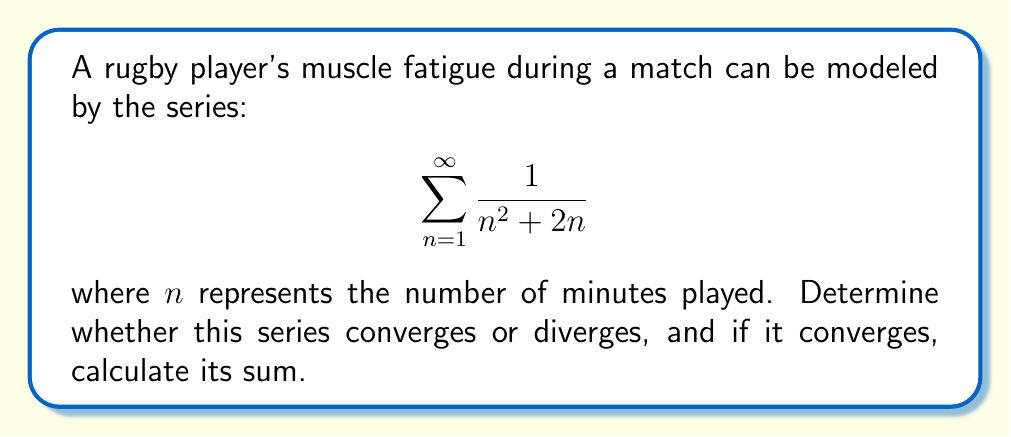Could you help me with this problem? To determine the convergence of this series, we can use the limit comparison test with a known convergent p-series.

Step 1: Choose a comparable series
Let's compare our series to the p-series $\sum_{n=1}^{\infty} \frac{1}{n^2}$, which is known to converge for $p > 1$.

Step 2: Calculate the limit of the ratio of the general terms
Let $a_n = \frac{1}{n^2 + 2n}$ and $b_n = \frac{1}{n^2}$

$$\lim_{n \to \infty} \frac{a_n}{b_n} = \lim_{n \to \infty} \frac{n^2}{n^2 + 2n} = \lim_{n \to \infty} \frac{1}{1 + \frac{2}{n}} = 1$$

Step 3: Apply the limit comparison test
Since the limit exists and is positive, our series converges if and only if the p-series converges. We know the p-series $\sum_{n=1}^{\infty} \frac{1}{n^2}$ converges, so our series also converges.

Step 4: Calculate the sum
To find the sum, we can use partial fractions decomposition:

$$\frac{1}{n^2 + 2n} = \frac{1}{n(n+2)} = \frac{1}{2}\left(\frac{1}{n} - \frac{1}{n+2}\right)$$

The series becomes:

$$\sum_{n=1}^{\infty} \frac{1}{n^2 + 2n} = \frac{1}{2}\sum_{n=1}^{\infty}\left(\frac{1}{n} - \frac{1}{n+2}\right)$$

This telescopes to:

$$\frac{1}{2}\left(1 + \frac{1}{2} - \frac{1}{3} - \frac{1}{4}\right) = \frac{1}{2}\left(\frac{3}{2} - \frac{7}{12}\right) = \frac{1}{2} \cdot \frac{11}{12} = \frac{11}{24}$$

Therefore, the series converges to $\frac{11}{24}$.
Answer: Converges; sum = $\frac{11}{24}$ 